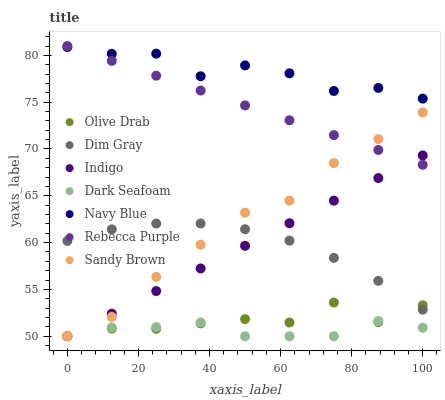Does Dark Seafoam have the minimum area under the curve?
Answer yes or no. Yes. Does Navy Blue have the maximum area under the curve?
Answer yes or no. Yes. Does Indigo have the minimum area under the curve?
Answer yes or no. No. Does Indigo have the maximum area under the curve?
Answer yes or no. No. Is Indigo the smoothest?
Answer yes or no. Yes. Is Navy Blue the roughest?
Answer yes or no. Yes. Is Navy Blue the smoothest?
Answer yes or no. No. Is Indigo the roughest?
Answer yes or no. No. Does Indigo have the lowest value?
Answer yes or no. Yes. Does Navy Blue have the lowest value?
Answer yes or no. No. Does Rebecca Purple have the highest value?
Answer yes or no. Yes. Does Indigo have the highest value?
Answer yes or no. No. Is Dim Gray less than Navy Blue?
Answer yes or no. Yes. Is Navy Blue greater than Sandy Brown?
Answer yes or no. Yes. Does Indigo intersect Dark Seafoam?
Answer yes or no. Yes. Is Indigo less than Dark Seafoam?
Answer yes or no. No. Is Indigo greater than Dark Seafoam?
Answer yes or no. No. Does Dim Gray intersect Navy Blue?
Answer yes or no. No. 